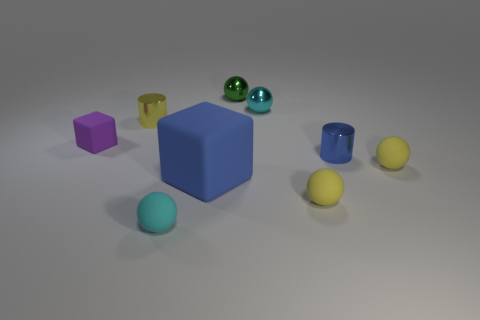Do the cyan object that is in front of the blue rubber object and the small cyan object that is on the right side of the big rubber thing have the same shape?
Your answer should be compact. Yes. How many rubber objects are both to the right of the tiny blue shiny cylinder and on the left side of the blue cylinder?
Ensure brevity in your answer.  0. How many other things are there of the same size as the yellow shiny cylinder?
Ensure brevity in your answer.  7. What is the ball that is behind the tiny cyan matte thing and left of the small cyan shiny ball made of?
Keep it short and to the point. Metal. There is a large object; is its color the same as the metal cylinder right of the tiny cyan shiny thing?
Ensure brevity in your answer.  Yes. The blue rubber thing that is the same shape as the purple thing is what size?
Offer a terse response. Large. The small metallic thing that is in front of the cyan shiny sphere and to the right of the tiny yellow metal object has what shape?
Offer a very short reply. Cylinder. Do the cyan shiny ball and the metal cylinder that is on the left side of the big blue cube have the same size?
Your answer should be very brief. Yes. The other thing that is the same shape as the small purple object is what color?
Give a very brief answer. Blue. There is a metallic ball that is on the right side of the tiny green metal ball; does it have the same size as the blue shiny object on the right side of the tiny purple matte object?
Your answer should be very brief. Yes. 